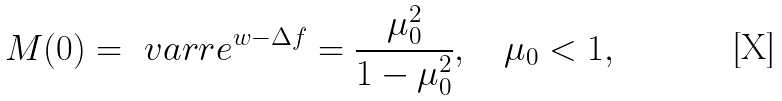<formula> <loc_0><loc_0><loc_500><loc_500>M ( 0 ) = \ v a r r { e ^ { w - \Delta f } } = \frac { \mu _ { 0 } ^ { 2 } } { 1 - \mu _ { 0 } ^ { 2 } } , \quad \mu _ { 0 } < 1 ,</formula> 